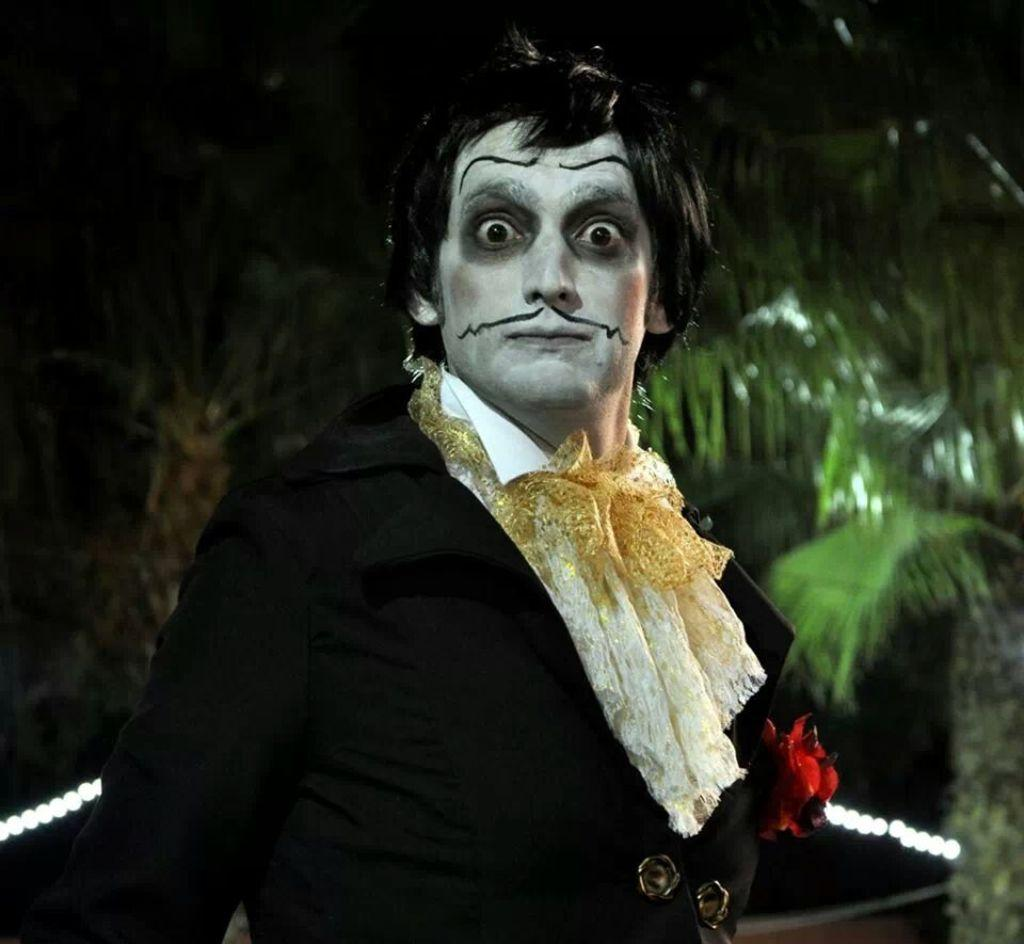What is the main subject of the image? There is a person in the image. Can you describe the person's appearance? The person has makeup on their face. What can be seen in the background of the image? There are trees and lights in the background of the image. What type of coil is being used by the person in the image? There is no coil present in the image. Who is the creator of the makeup worn by the person in the image? The provided facts do not mention the creator of the makeup. 